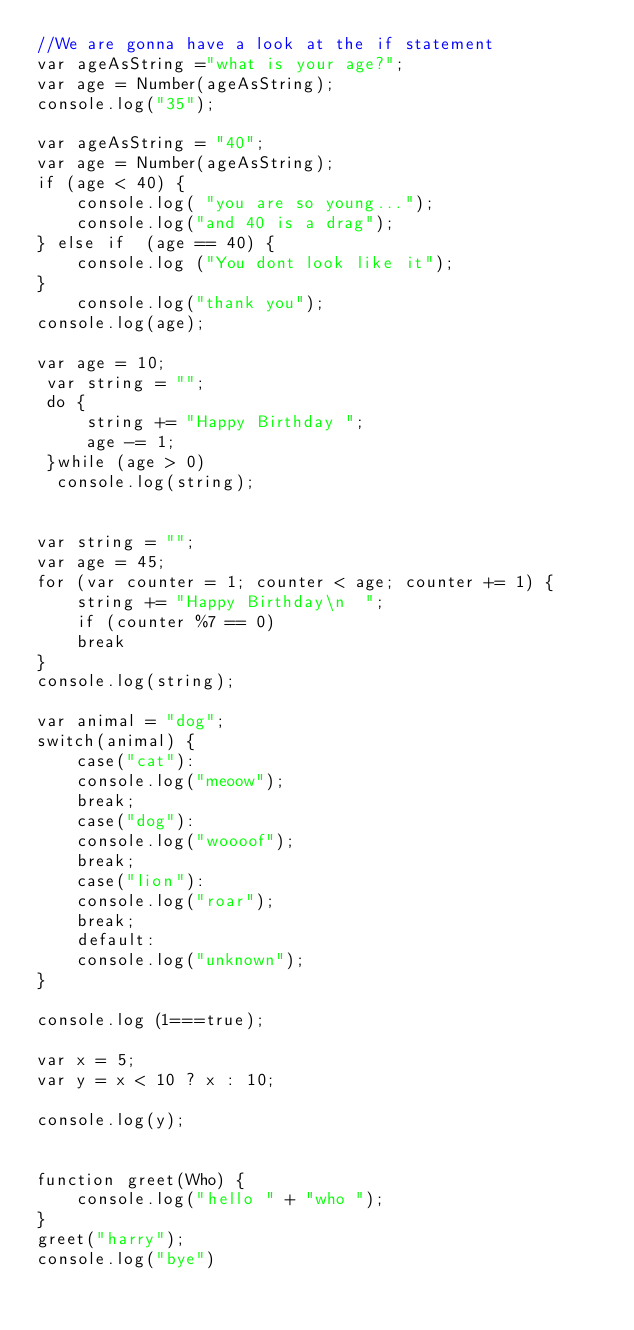<code> <loc_0><loc_0><loc_500><loc_500><_JavaScript_>//We are gonna have a look at the if statement
var ageAsString ="what is your age?";
var age = Number(ageAsString);
console.log("35");

var ageAsString = "40";
var age = Number(ageAsString);
if (age < 40) {
    console.log( "you are so young...");
    console.log("and 40 is a drag");
} else if  (age == 40) {
    console.log ("You dont look like it");
}
    console.log("thank you"); 
console.log(age);

var age = 10;
 var string = "";
 do {
     string += "Happy Birthday ";
     age -= 1;
 }while (age > 0)
  console.log(string);


var string = "";
var age = 45;
for (var counter = 1; counter < age; counter += 1) { 
    string += "Happy Birthday\n  ";
    if (counter %7 == 0)
    break
}
console.log(string);

var animal = "dog";
switch(animal) {
    case("cat"):
    console.log("meoow");
    break;
    case("dog"):
    console.log("woooof");
    break;
    case("lion"):
    console.log("roar");
    break;
    default:
    console.log("unknown");
}

console.log (1===true);

var x = 5;
var y = x < 10 ? x : 10;
 
console.log(y);


function greet(Who) {
    console.log("hello " + "who ");
}
greet("harry");
console.log("bye")</code> 